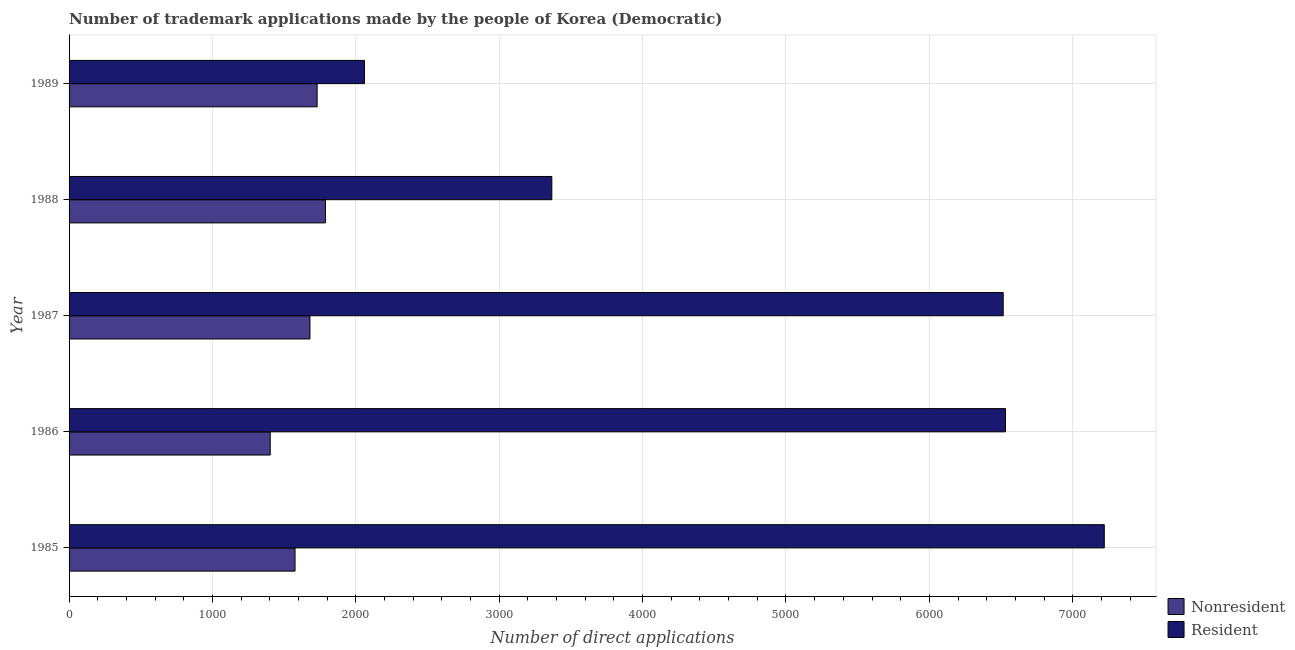How many different coloured bars are there?
Your answer should be compact. 2. How many bars are there on the 5th tick from the bottom?
Provide a succinct answer. 2. In how many cases, is the number of bars for a given year not equal to the number of legend labels?
Offer a very short reply. 0. What is the number of trademark applications made by non residents in 1985?
Ensure brevity in your answer.  1576. Across all years, what is the maximum number of trademark applications made by non residents?
Offer a very short reply. 1788. Across all years, what is the minimum number of trademark applications made by residents?
Provide a short and direct response. 2060. In which year was the number of trademark applications made by non residents minimum?
Ensure brevity in your answer.  1986. What is the total number of trademark applications made by residents in the graph?
Make the answer very short. 2.57e+04. What is the difference between the number of trademark applications made by non residents in 1985 and that in 1987?
Ensure brevity in your answer.  -104. What is the difference between the number of trademark applications made by residents in 1985 and the number of trademark applications made by non residents in 1989?
Offer a very short reply. 5490. What is the average number of trademark applications made by residents per year?
Make the answer very short. 5138.6. In the year 1988, what is the difference between the number of trademark applications made by non residents and number of trademark applications made by residents?
Your answer should be very brief. -1579. In how many years, is the number of trademark applications made by residents greater than 5800 ?
Your answer should be very brief. 3. What is the ratio of the number of trademark applications made by non residents in 1986 to that in 1987?
Ensure brevity in your answer.  0.83. What is the difference between the highest and the second highest number of trademark applications made by residents?
Your answer should be compact. 689. What is the difference between the highest and the lowest number of trademark applications made by non residents?
Offer a terse response. 385. In how many years, is the number of trademark applications made by non residents greater than the average number of trademark applications made by non residents taken over all years?
Your response must be concise. 3. What does the 1st bar from the top in 1986 represents?
Your answer should be compact. Resident. What does the 2nd bar from the bottom in 1985 represents?
Make the answer very short. Resident. What is the difference between two consecutive major ticks on the X-axis?
Ensure brevity in your answer.  1000. Does the graph contain grids?
Give a very brief answer. Yes. Where does the legend appear in the graph?
Keep it short and to the point. Bottom right. How many legend labels are there?
Ensure brevity in your answer.  2. How are the legend labels stacked?
Provide a short and direct response. Vertical. What is the title of the graph?
Provide a succinct answer. Number of trademark applications made by the people of Korea (Democratic). What is the label or title of the X-axis?
Ensure brevity in your answer.  Number of direct applications. What is the label or title of the Y-axis?
Your answer should be compact. Year. What is the Number of direct applications of Nonresident in 1985?
Your response must be concise. 1576. What is the Number of direct applications in Resident in 1985?
Provide a short and direct response. 7220. What is the Number of direct applications in Nonresident in 1986?
Your answer should be compact. 1403. What is the Number of direct applications in Resident in 1986?
Your answer should be very brief. 6531. What is the Number of direct applications of Nonresident in 1987?
Ensure brevity in your answer.  1680. What is the Number of direct applications in Resident in 1987?
Provide a succinct answer. 6515. What is the Number of direct applications in Nonresident in 1988?
Your answer should be compact. 1788. What is the Number of direct applications of Resident in 1988?
Offer a terse response. 3367. What is the Number of direct applications in Nonresident in 1989?
Ensure brevity in your answer.  1730. What is the Number of direct applications of Resident in 1989?
Your answer should be compact. 2060. Across all years, what is the maximum Number of direct applications in Nonresident?
Your answer should be very brief. 1788. Across all years, what is the maximum Number of direct applications of Resident?
Ensure brevity in your answer.  7220. Across all years, what is the minimum Number of direct applications in Nonresident?
Provide a short and direct response. 1403. Across all years, what is the minimum Number of direct applications of Resident?
Provide a succinct answer. 2060. What is the total Number of direct applications in Nonresident in the graph?
Your answer should be very brief. 8177. What is the total Number of direct applications in Resident in the graph?
Provide a short and direct response. 2.57e+04. What is the difference between the Number of direct applications of Nonresident in 1985 and that in 1986?
Offer a terse response. 173. What is the difference between the Number of direct applications of Resident in 1985 and that in 1986?
Your answer should be very brief. 689. What is the difference between the Number of direct applications of Nonresident in 1985 and that in 1987?
Make the answer very short. -104. What is the difference between the Number of direct applications of Resident in 1985 and that in 1987?
Make the answer very short. 705. What is the difference between the Number of direct applications in Nonresident in 1985 and that in 1988?
Provide a succinct answer. -212. What is the difference between the Number of direct applications of Resident in 1985 and that in 1988?
Your response must be concise. 3853. What is the difference between the Number of direct applications in Nonresident in 1985 and that in 1989?
Give a very brief answer. -154. What is the difference between the Number of direct applications in Resident in 1985 and that in 1989?
Ensure brevity in your answer.  5160. What is the difference between the Number of direct applications of Nonresident in 1986 and that in 1987?
Provide a succinct answer. -277. What is the difference between the Number of direct applications in Resident in 1986 and that in 1987?
Provide a succinct answer. 16. What is the difference between the Number of direct applications of Nonresident in 1986 and that in 1988?
Keep it short and to the point. -385. What is the difference between the Number of direct applications in Resident in 1986 and that in 1988?
Your response must be concise. 3164. What is the difference between the Number of direct applications of Nonresident in 1986 and that in 1989?
Make the answer very short. -327. What is the difference between the Number of direct applications of Resident in 1986 and that in 1989?
Provide a short and direct response. 4471. What is the difference between the Number of direct applications in Nonresident in 1987 and that in 1988?
Offer a very short reply. -108. What is the difference between the Number of direct applications in Resident in 1987 and that in 1988?
Your answer should be compact. 3148. What is the difference between the Number of direct applications in Nonresident in 1987 and that in 1989?
Offer a very short reply. -50. What is the difference between the Number of direct applications in Resident in 1987 and that in 1989?
Your answer should be very brief. 4455. What is the difference between the Number of direct applications in Nonresident in 1988 and that in 1989?
Offer a very short reply. 58. What is the difference between the Number of direct applications in Resident in 1988 and that in 1989?
Provide a short and direct response. 1307. What is the difference between the Number of direct applications in Nonresident in 1985 and the Number of direct applications in Resident in 1986?
Make the answer very short. -4955. What is the difference between the Number of direct applications of Nonresident in 1985 and the Number of direct applications of Resident in 1987?
Provide a short and direct response. -4939. What is the difference between the Number of direct applications of Nonresident in 1985 and the Number of direct applications of Resident in 1988?
Make the answer very short. -1791. What is the difference between the Number of direct applications in Nonresident in 1985 and the Number of direct applications in Resident in 1989?
Your answer should be very brief. -484. What is the difference between the Number of direct applications of Nonresident in 1986 and the Number of direct applications of Resident in 1987?
Your response must be concise. -5112. What is the difference between the Number of direct applications in Nonresident in 1986 and the Number of direct applications in Resident in 1988?
Your answer should be compact. -1964. What is the difference between the Number of direct applications in Nonresident in 1986 and the Number of direct applications in Resident in 1989?
Make the answer very short. -657. What is the difference between the Number of direct applications of Nonresident in 1987 and the Number of direct applications of Resident in 1988?
Ensure brevity in your answer.  -1687. What is the difference between the Number of direct applications in Nonresident in 1987 and the Number of direct applications in Resident in 1989?
Offer a terse response. -380. What is the difference between the Number of direct applications of Nonresident in 1988 and the Number of direct applications of Resident in 1989?
Give a very brief answer. -272. What is the average Number of direct applications of Nonresident per year?
Provide a short and direct response. 1635.4. What is the average Number of direct applications in Resident per year?
Your response must be concise. 5138.6. In the year 1985, what is the difference between the Number of direct applications in Nonresident and Number of direct applications in Resident?
Your response must be concise. -5644. In the year 1986, what is the difference between the Number of direct applications in Nonresident and Number of direct applications in Resident?
Keep it short and to the point. -5128. In the year 1987, what is the difference between the Number of direct applications of Nonresident and Number of direct applications of Resident?
Ensure brevity in your answer.  -4835. In the year 1988, what is the difference between the Number of direct applications in Nonresident and Number of direct applications in Resident?
Give a very brief answer. -1579. In the year 1989, what is the difference between the Number of direct applications in Nonresident and Number of direct applications in Resident?
Offer a terse response. -330. What is the ratio of the Number of direct applications in Nonresident in 1985 to that in 1986?
Your answer should be compact. 1.12. What is the ratio of the Number of direct applications in Resident in 1985 to that in 1986?
Keep it short and to the point. 1.11. What is the ratio of the Number of direct applications in Nonresident in 1985 to that in 1987?
Your answer should be very brief. 0.94. What is the ratio of the Number of direct applications of Resident in 1985 to that in 1987?
Offer a very short reply. 1.11. What is the ratio of the Number of direct applications in Nonresident in 1985 to that in 1988?
Offer a terse response. 0.88. What is the ratio of the Number of direct applications of Resident in 1985 to that in 1988?
Offer a terse response. 2.14. What is the ratio of the Number of direct applications of Nonresident in 1985 to that in 1989?
Give a very brief answer. 0.91. What is the ratio of the Number of direct applications in Resident in 1985 to that in 1989?
Provide a succinct answer. 3.5. What is the ratio of the Number of direct applications in Nonresident in 1986 to that in 1987?
Provide a short and direct response. 0.84. What is the ratio of the Number of direct applications in Nonresident in 1986 to that in 1988?
Provide a short and direct response. 0.78. What is the ratio of the Number of direct applications in Resident in 1986 to that in 1988?
Ensure brevity in your answer.  1.94. What is the ratio of the Number of direct applications in Nonresident in 1986 to that in 1989?
Your answer should be compact. 0.81. What is the ratio of the Number of direct applications of Resident in 1986 to that in 1989?
Keep it short and to the point. 3.17. What is the ratio of the Number of direct applications in Nonresident in 1987 to that in 1988?
Your response must be concise. 0.94. What is the ratio of the Number of direct applications in Resident in 1987 to that in 1988?
Offer a terse response. 1.94. What is the ratio of the Number of direct applications of Nonresident in 1987 to that in 1989?
Provide a succinct answer. 0.97. What is the ratio of the Number of direct applications in Resident in 1987 to that in 1989?
Offer a terse response. 3.16. What is the ratio of the Number of direct applications of Nonresident in 1988 to that in 1989?
Offer a terse response. 1.03. What is the ratio of the Number of direct applications in Resident in 1988 to that in 1989?
Offer a very short reply. 1.63. What is the difference between the highest and the second highest Number of direct applications in Resident?
Make the answer very short. 689. What is the difference between the highest and the lowest Number of direct applications of Nonresident?
Your answer should be very brief. 385. What is the difference between the highest and the lowest Number of direct applications in Resident?
Your response must be concise. 5160. 